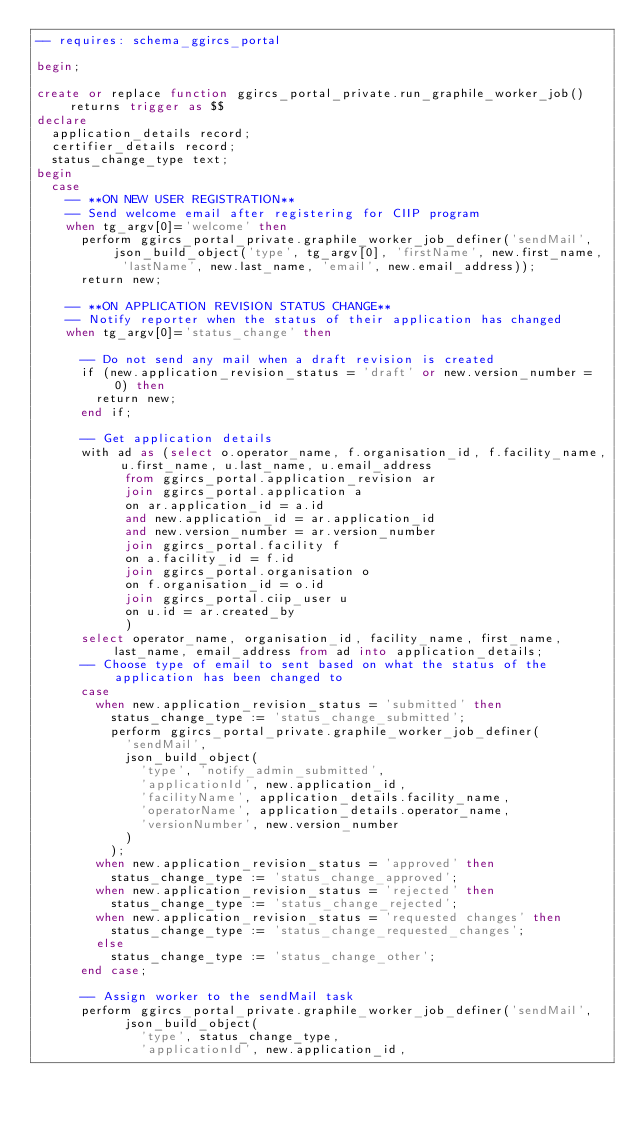<code> <loc_0><loc_0><loc_500><loc_500><_SQL_>-- requires: schema_ggircs_portal

begin;

create or replace function ggircs_portal_private.run_graphile_worker_job() returns trigger as $$
declare
  application_details record;
  certifier_details record;
  status_change_type text;
begin
  case
    -- **ON NEW USER REGISTRATION**
    -- Send welcome email after registering for CIIP program
    when tg_argv[0]='welcome' then
      perform ggircs_portal_private.graphile_worker_job_definer('sendMail', json_build_object('type', tg_argv[0], 'firstName', new.first_name, 'lastName', new.last_name, 'email', new.email_address));
      return new;

    -- **ON APPLICATION REVISION STATUS CHANGE**
    -- Notify reporter when the status of their application has changed
    when tg_argv[0]='status_change' then

      -- Do not send any mail when a draft revision is created
      if (new.application_revision_status = 'draft' or new.version_number = 0) then
        return new;
      end if;

      -- Get application details
      with ad as (select o.operator_name, f.organisation_id, f.facility_name, u.first_name, u.last_name, u.email_address
            from ggircs_portal.application_revision ar
            join ggircs_portal.application a
            on ar.application_id = a.id
            and new.application_id = ar.application_id
            and new.version_number = ar.version_number
            join ggircs_portal.facility f
            on a.facility_id = f.id
            join ggircs_portal.organisation o
            on f.organisation_id = o.id
            join ggircs_portal.ciip_user u
            on u.id = ar.created_by
            )
      select operator_name, organisation_id, facility_name, first_name, last_name, email_address from ad into application_details;
      -- Choose type of email to sent based on what the status of the application has been changed to
      case
        when new.application_revision_status = 'submitted' then
          status_change_type := 'status_change_submitted';
          perform ggircs_portal_private.graphile_worker_job_definer(
            'sendMail',
            json_build_object(
              'type', 'notify_admin_submitted',
              'applicationId', new.application_id,
              'facilityName', application_details.facility_name,
              'operatorName', application_details.operator_name,
              'versionNumber', new.version_number
            )
          );
        when new.application_revision_status = 'approved' then
          status_change_type := 'status_change_approved';
        when new.application_revision_status = 'rejected' then
          status_change_type := 'status_change_rejected';
        when new.application_revision_status = 'requested changes' then
          status_change_type := 'status_change_requested_changes';
        else
          status_change_type := 'status_change_other';
      end case;

      -- Assign worker to the sendMail task
      perform ggircs_portal_private.graphile_worker_job_definer('sendMail',
            json_build_object(
              'type', status_change_type,
              'applicationId', new.application_id,</code> 